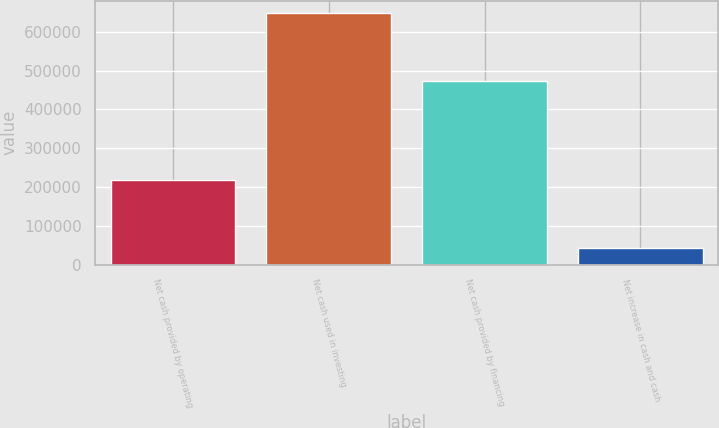<chart> <loc_0><loc_0><loc_500><loc_500><bar_chart><fcel>Net cash provided by operating<fcel>Net cash used in investing<fcel>Net cash provided by financing<fcel>Net increase in cash and cash<nl><fcel>217808<fcel>647751<fcel>471925<fcel>41982<nl></chart> 